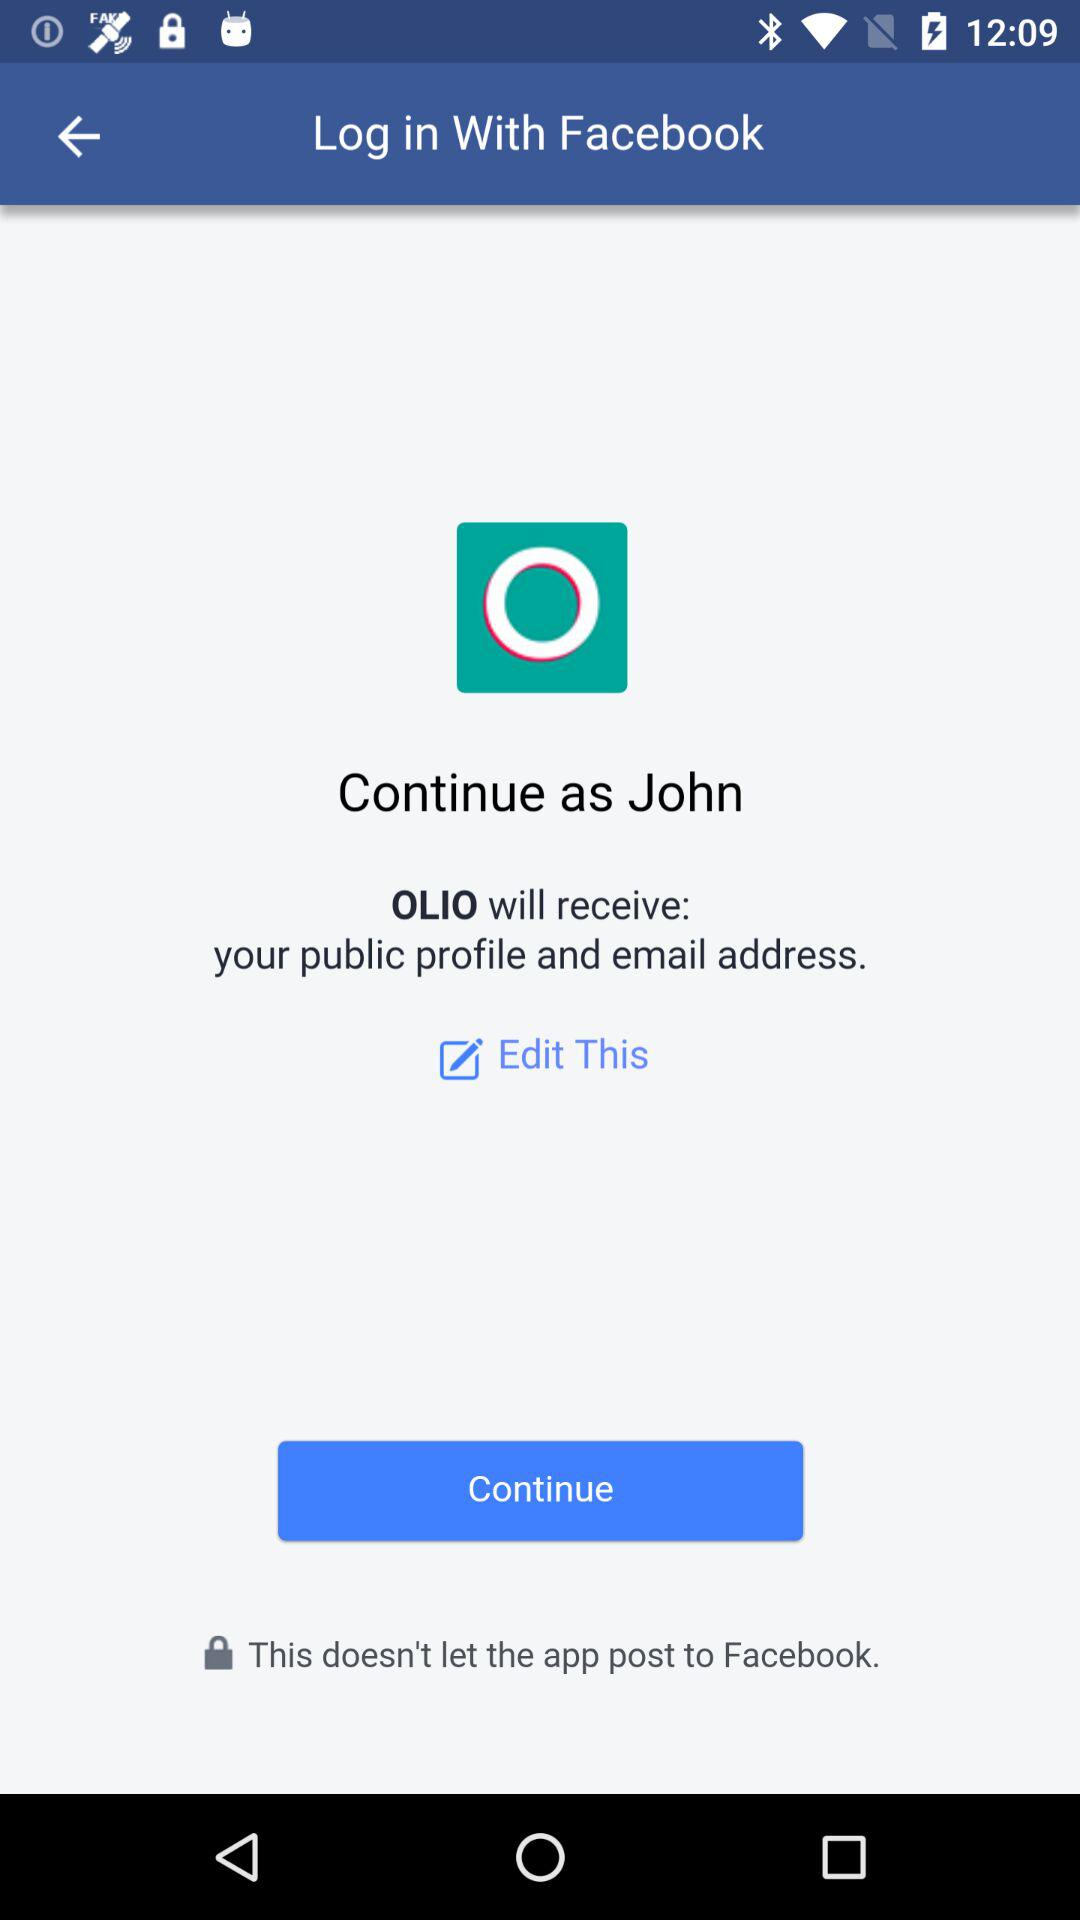What is the name of the user? The name of the user is John. 